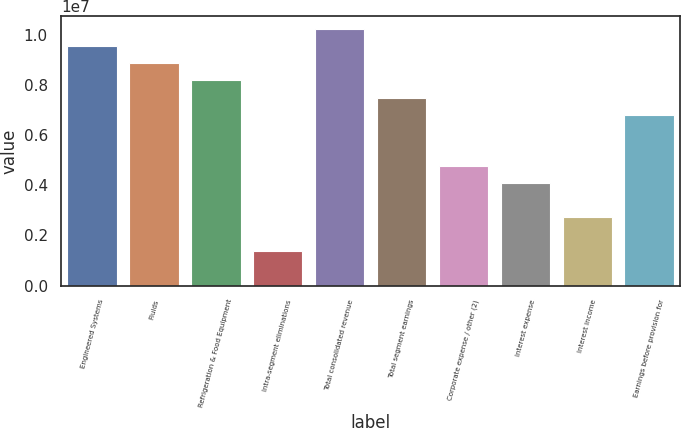<chart> <loc_0><loc_0><loc_500><loc_500><bar_chart><fcel>Engineered Systems<fcel>Fluids<fcel>Refrigeration & Food Equipment<fcel>Intra-segment eliminations<fcel>Total consolidated revenue<fcel>Total segment earnings<fcel>Corporate expense / other (2)<fcel>Interest expense<fcel>Interest income<fcel>Earnings before provision for<nl><fcel>9.54924e+06<fcel>8.86715e+06<fcel>8.18506e+06<fcel>1.36419e+06<fcel>1.02313e+07<fcel>7.50297e+06<fcel>4.77462e+06<fcel>4.09254e+06<fcel>2.72836e+06<fcel>6.82089e+06<nl></chart> 